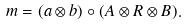<formula> <loc_0><loc_0><loc_500><loc_500>m = ( a \otimes b ) \circ ( A \otimes R \otimes B ) .</formula> 